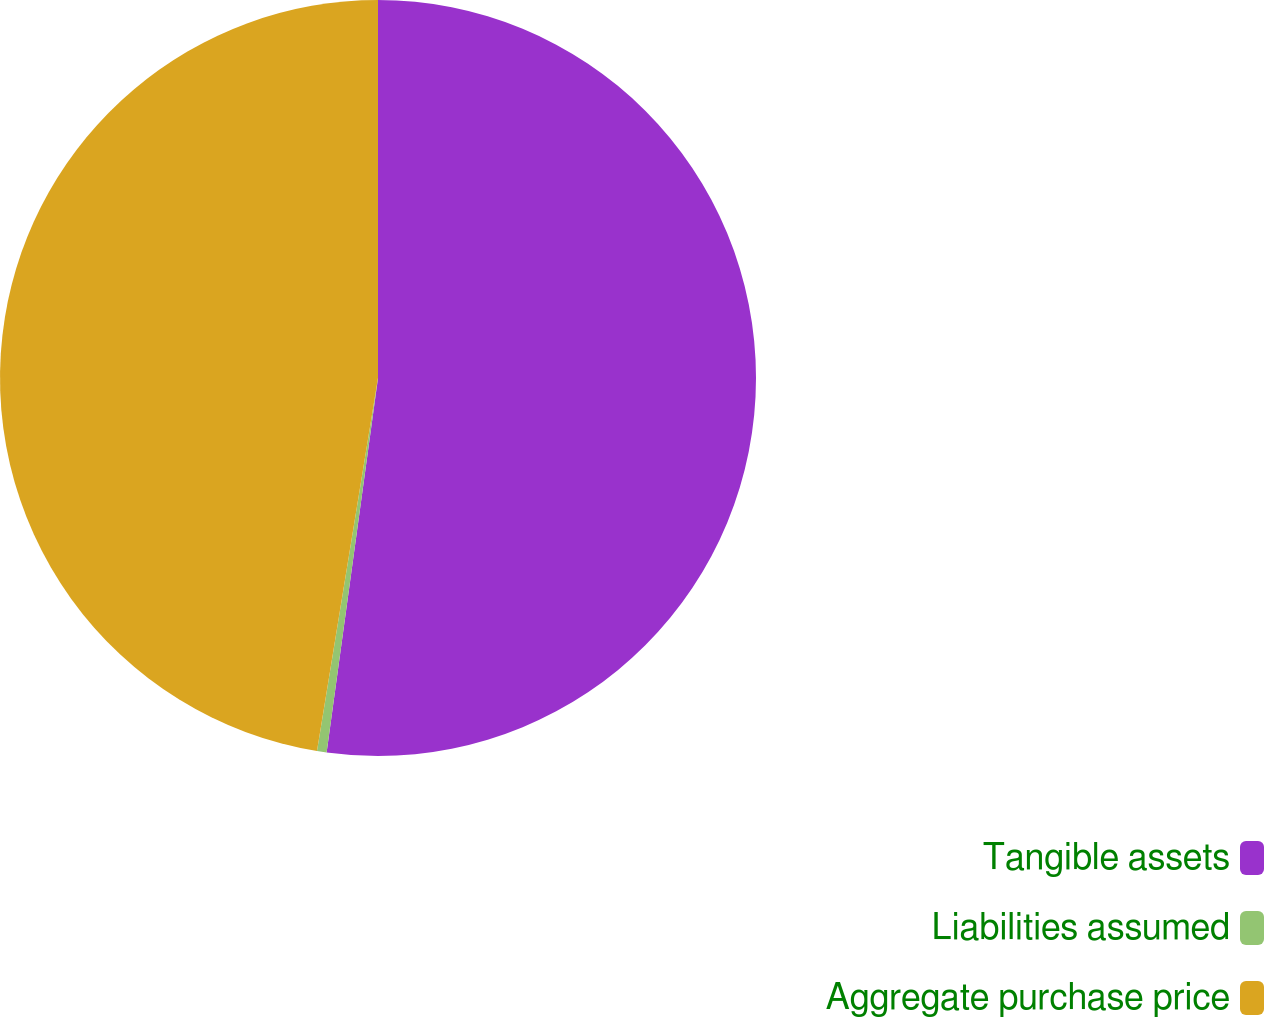Convert chart. <chart><loc_0><loc_0><loc_500><loc_500><pie_chart><fcel>Tangible assets<fcel>Liabilities assumed<fcel>Aggregate purchase price<nl><fcel>52.17%<fcel>0.41%<fcel>47.42%<nl></chart> 